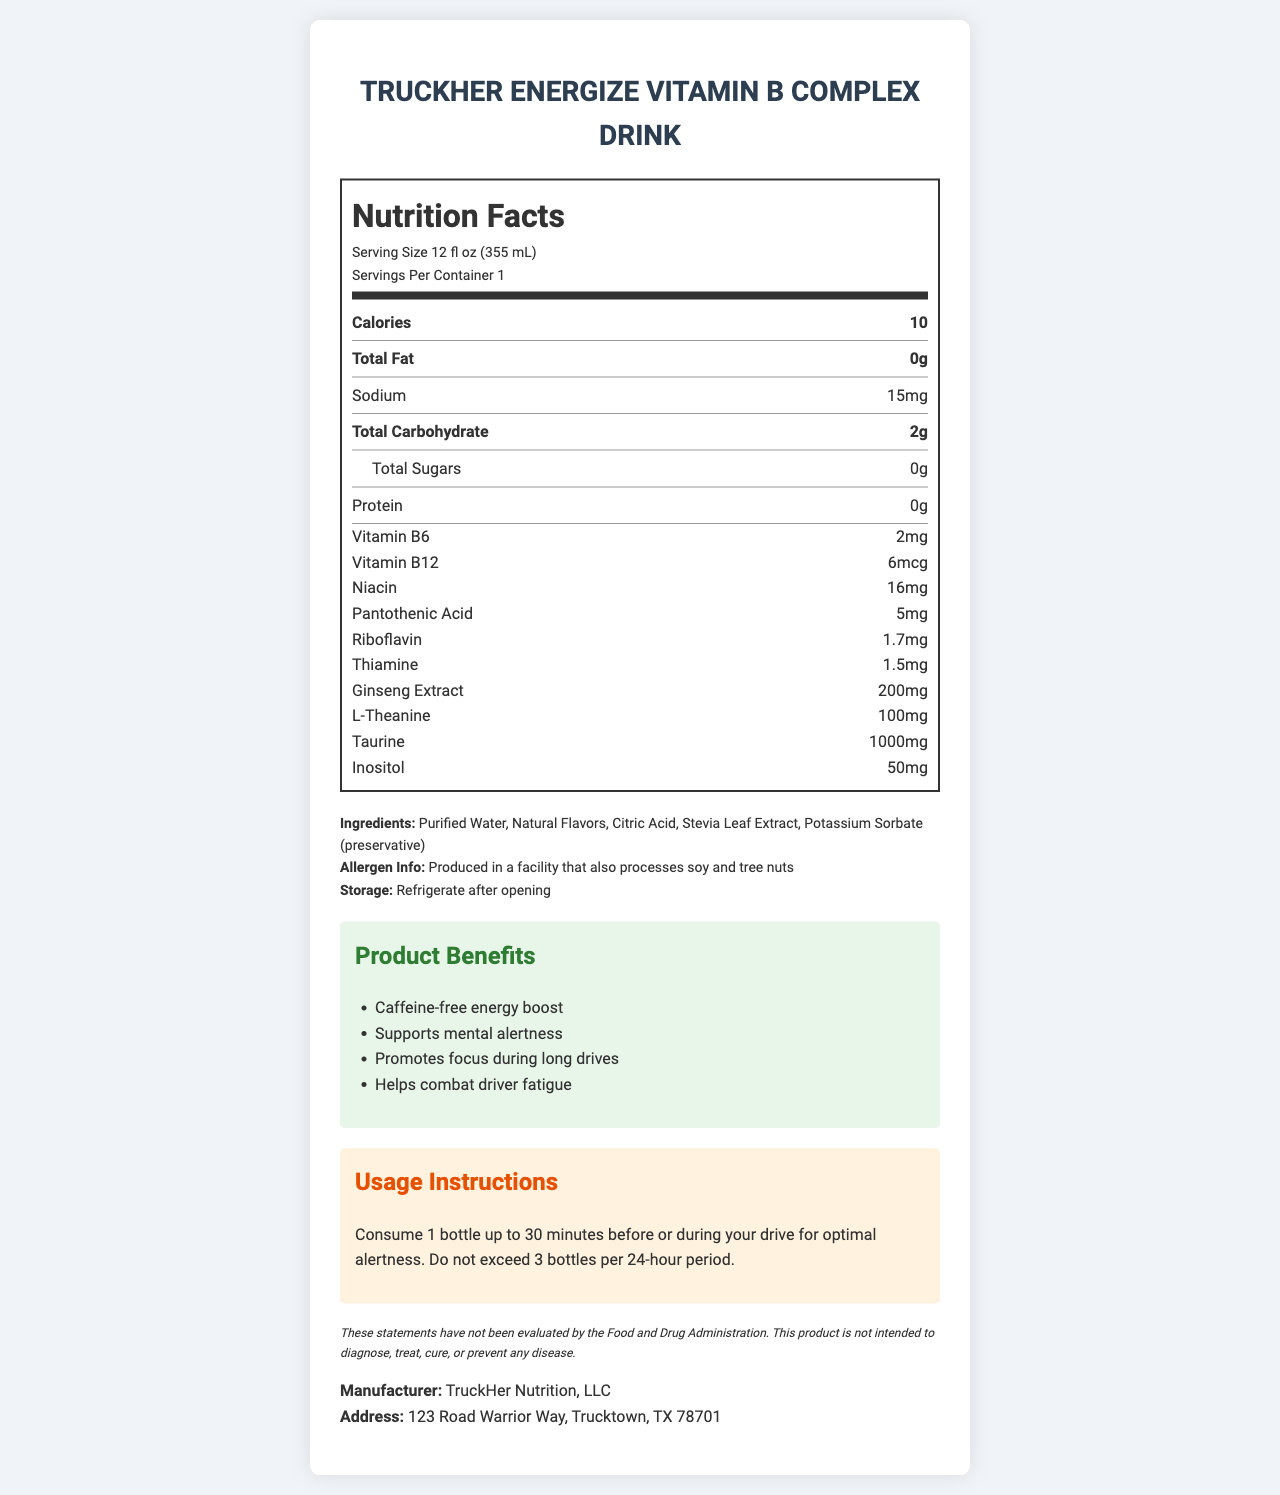What is the serving size for TruckHer Energize Vitamin B Complex Drink? The serving size is clearly stated at the beginning of the nutrition facts label.
Answer: 12 fl oz (355 mL) How many calories are in one serving of this drink? The calories per serving are listed under the "Nutrition Facts" section.
Answer: 10 What is the amount of sodium in one serving? The sodium content is mentioned under the "Nutrition Facts" with other nutrients.
Answer: 15mg What ingredient is listed as a preservative in this drink? Potassium Sorbate is mentioned as a preservative under the "Ingredients" section.
Answer: Potassium Sorbate How much Vitamin B6 does one serving contain? This information is listed under the vitamins and minerals section of the nutrition facts.
Answer: 2mg Which of the following is NOT an ingredient in TruckHer Energize Vitamin B Complex Drink? A) Citric Acid B) Stevia Leaf Extract C) Caffeine Caffeine is not listed in the ingredient list, as it is a caffeine-free beverage.
Answer: C) Caffeine How many milligrams of taurine are in one bottle? A) 200mg B) 1000mg C) 50mg D) 355mg The taurine content is listed as 1000mg in the nutrition facts section.
Answer: B) 1000mg Is this product produced in a facility that processes soy and tree nuts? Yes/No The allergen information at the bottom specifies that the product is produced in a facility that also processes soy and tree nuts.
Answer: Yes Summarize the key points of the Nutrition Facts Label for TruckHer Energize Vitamin B Complex Drink. The label highlights the nutritional content, including vitamins and minerals, provides product benefits such as mental alertness and combating fatigue, lists all ingredients, and includes usage instructions and allergen information.
Answer: The label provides detailed nutrition information on a caffeine-free, low-calorie energy drink designed for mental alertness and combating driver fatigue. It lists vitamins, essential nutrients, ingredients, allergen information, storage instructions, and the benefits of the product. Does this product contain any added sugars? The label specifies that the total sugars are 0g, indicating there are no added sugars.
Answer: No How many bottles can you consume in a 24-hour period? The usage instructions indicate not to exceed 3 bottles in a 24-hour period.
Answer: 3 bottles What benefits does the TruckHer Energize Vitamin B Complex Drink offer to drivers? The benefits are clearly listed under the "Product Benefits" section on the label.
Answer: Caffeine-free energy boost, supports mental alertness, promotes focus during long drives, helps combat driver fatigue What is the address of the manufacturer? The manufacturer's address is provided at the bottom of the label.
Answer: 123 Road Warrior Way, Trucktown, TX 78701 What is the purpose of citric acid in the ingredients list? The document lists citric acid as an ingredient but does not specify its purpose.
Answer: Not enough information 